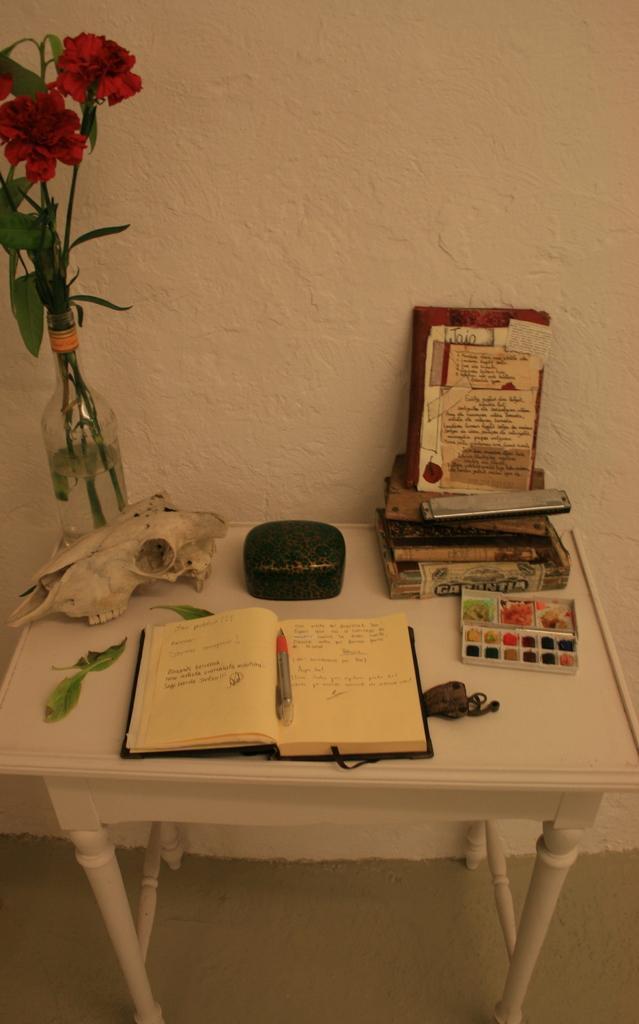How would you summarize this image in a sentence or two? In this Image I see a table on which there is a book, pen and a plant and other things and I can also see a wall. 